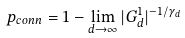Convert formula to latex. <formula><loc_0><loc_0><loc_500><loc_500>p _ { c o n n } = 1 - \lim _ { d \to \infty } | G ^ { 1 } _ { d } | ^ { - 1 / \gamma _ { d } }</formula> 